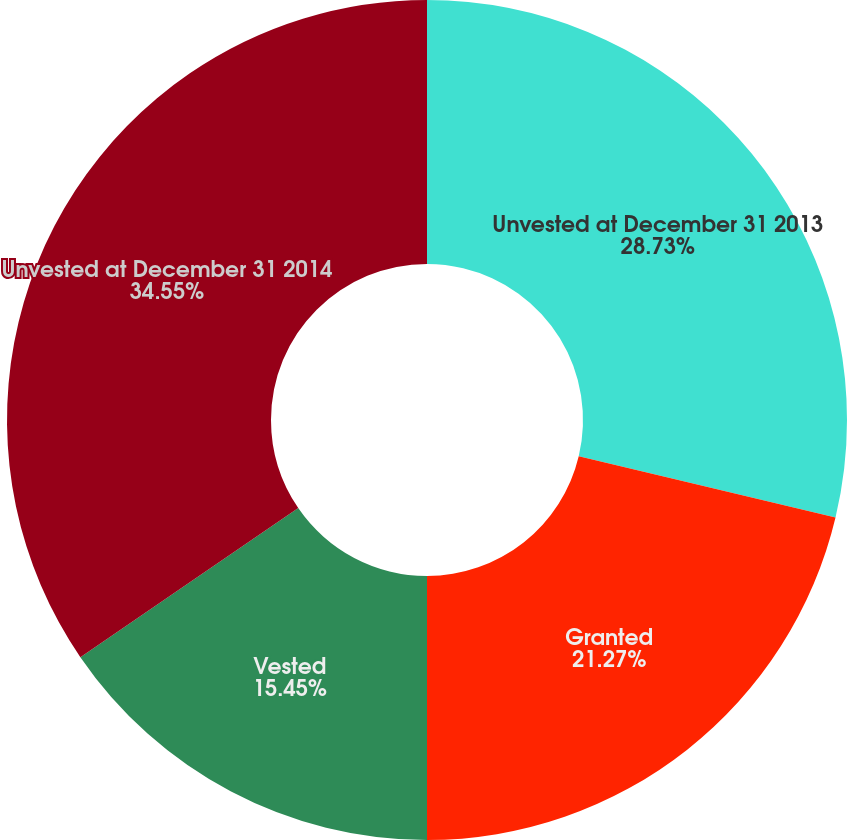Convert chart to OTSL. <chart><loc_0><loc_0><loc_500><loc_500><pie_chart><fcel>Unvested at December 31 2013<fcel>Granted<fcel>Vested<fcel>Unvested at December 31 2014<nl><fcel>28.73%<fcel>21.27%<fcel>15.45%<fcel>34.55%<nl></chart> 